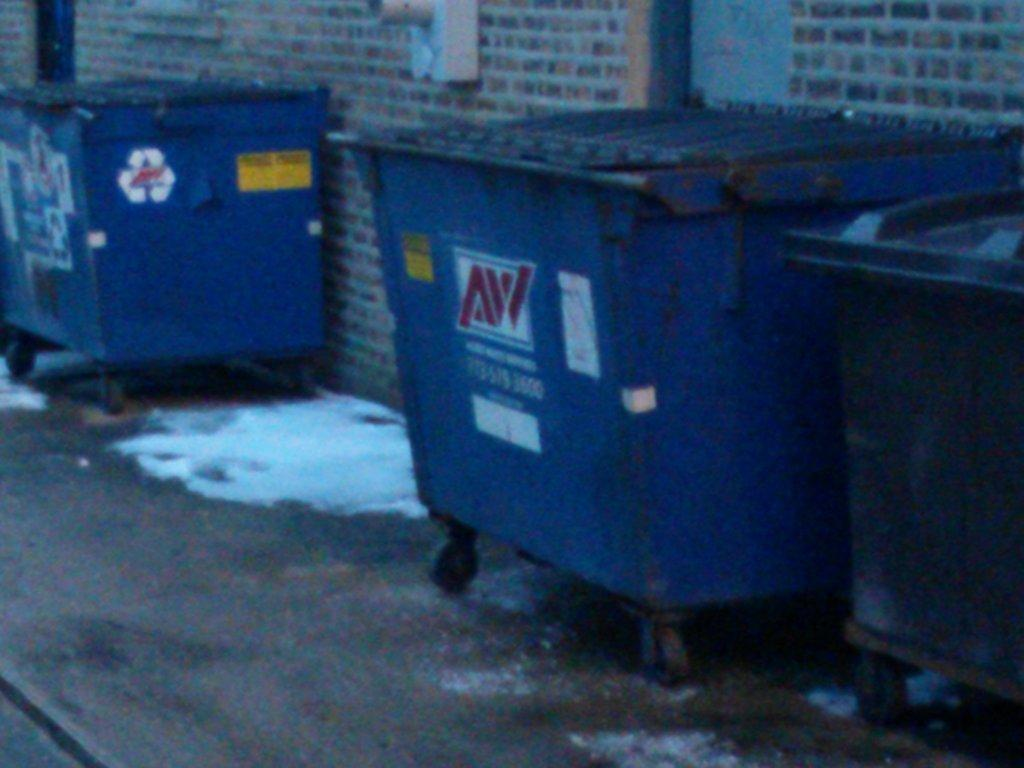<image>
Render a clear and concise summary of the photo. A blue trash dumpster has AW in red letters against a white background. 